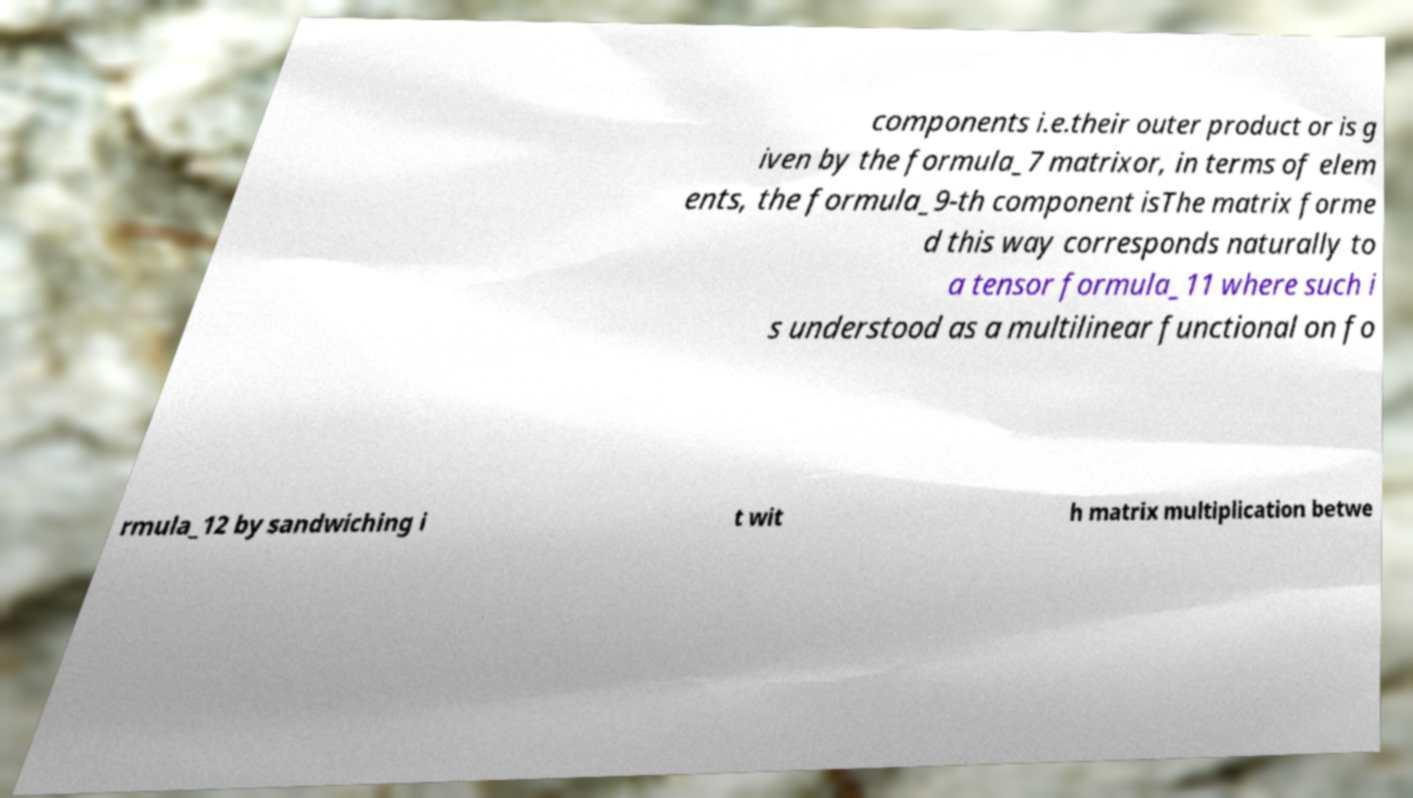Please identify and transcribe the text found in this image. components i.e.their outer product or is g iven by the formula_7 matrixor, in terms of elem ents, the formula_9-th component isThe matrix forme d this way corresponds naturally to a tensor formula_11 where such i s understood as a multilinear functional on fo rmula_12 by sandwiching i t wit h matrix multiplication betwe 